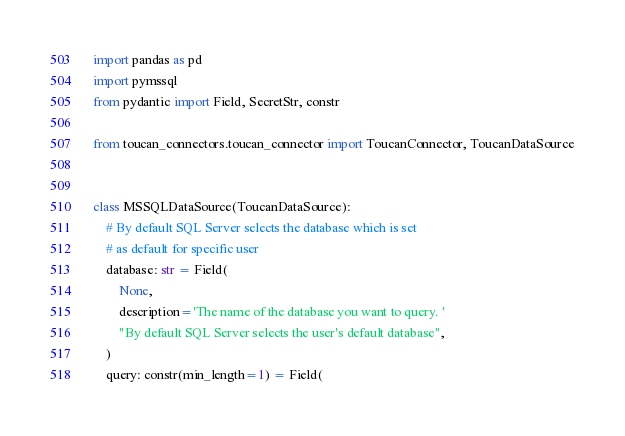Convert code to text. <code><loc_0><loc_0><loc_500><loc_500><_Python_>import pandas as pd
import pymssql
from pydantic import Field, SecretStr, constr

from toucan_connectors.toucan_connector import ToucanConnector, ToucanDataSource


class MSSQLDataSource(ToucanDataSource):
    # By default SQL Server selects the database which is set
    # as default for specific user
    database: str = Field(
        None,
        description='The name of the database you want to query. '
        "By default SQL Server selects the user's default database",
    )
    query: constr(min_length=1) = Field(</code> 